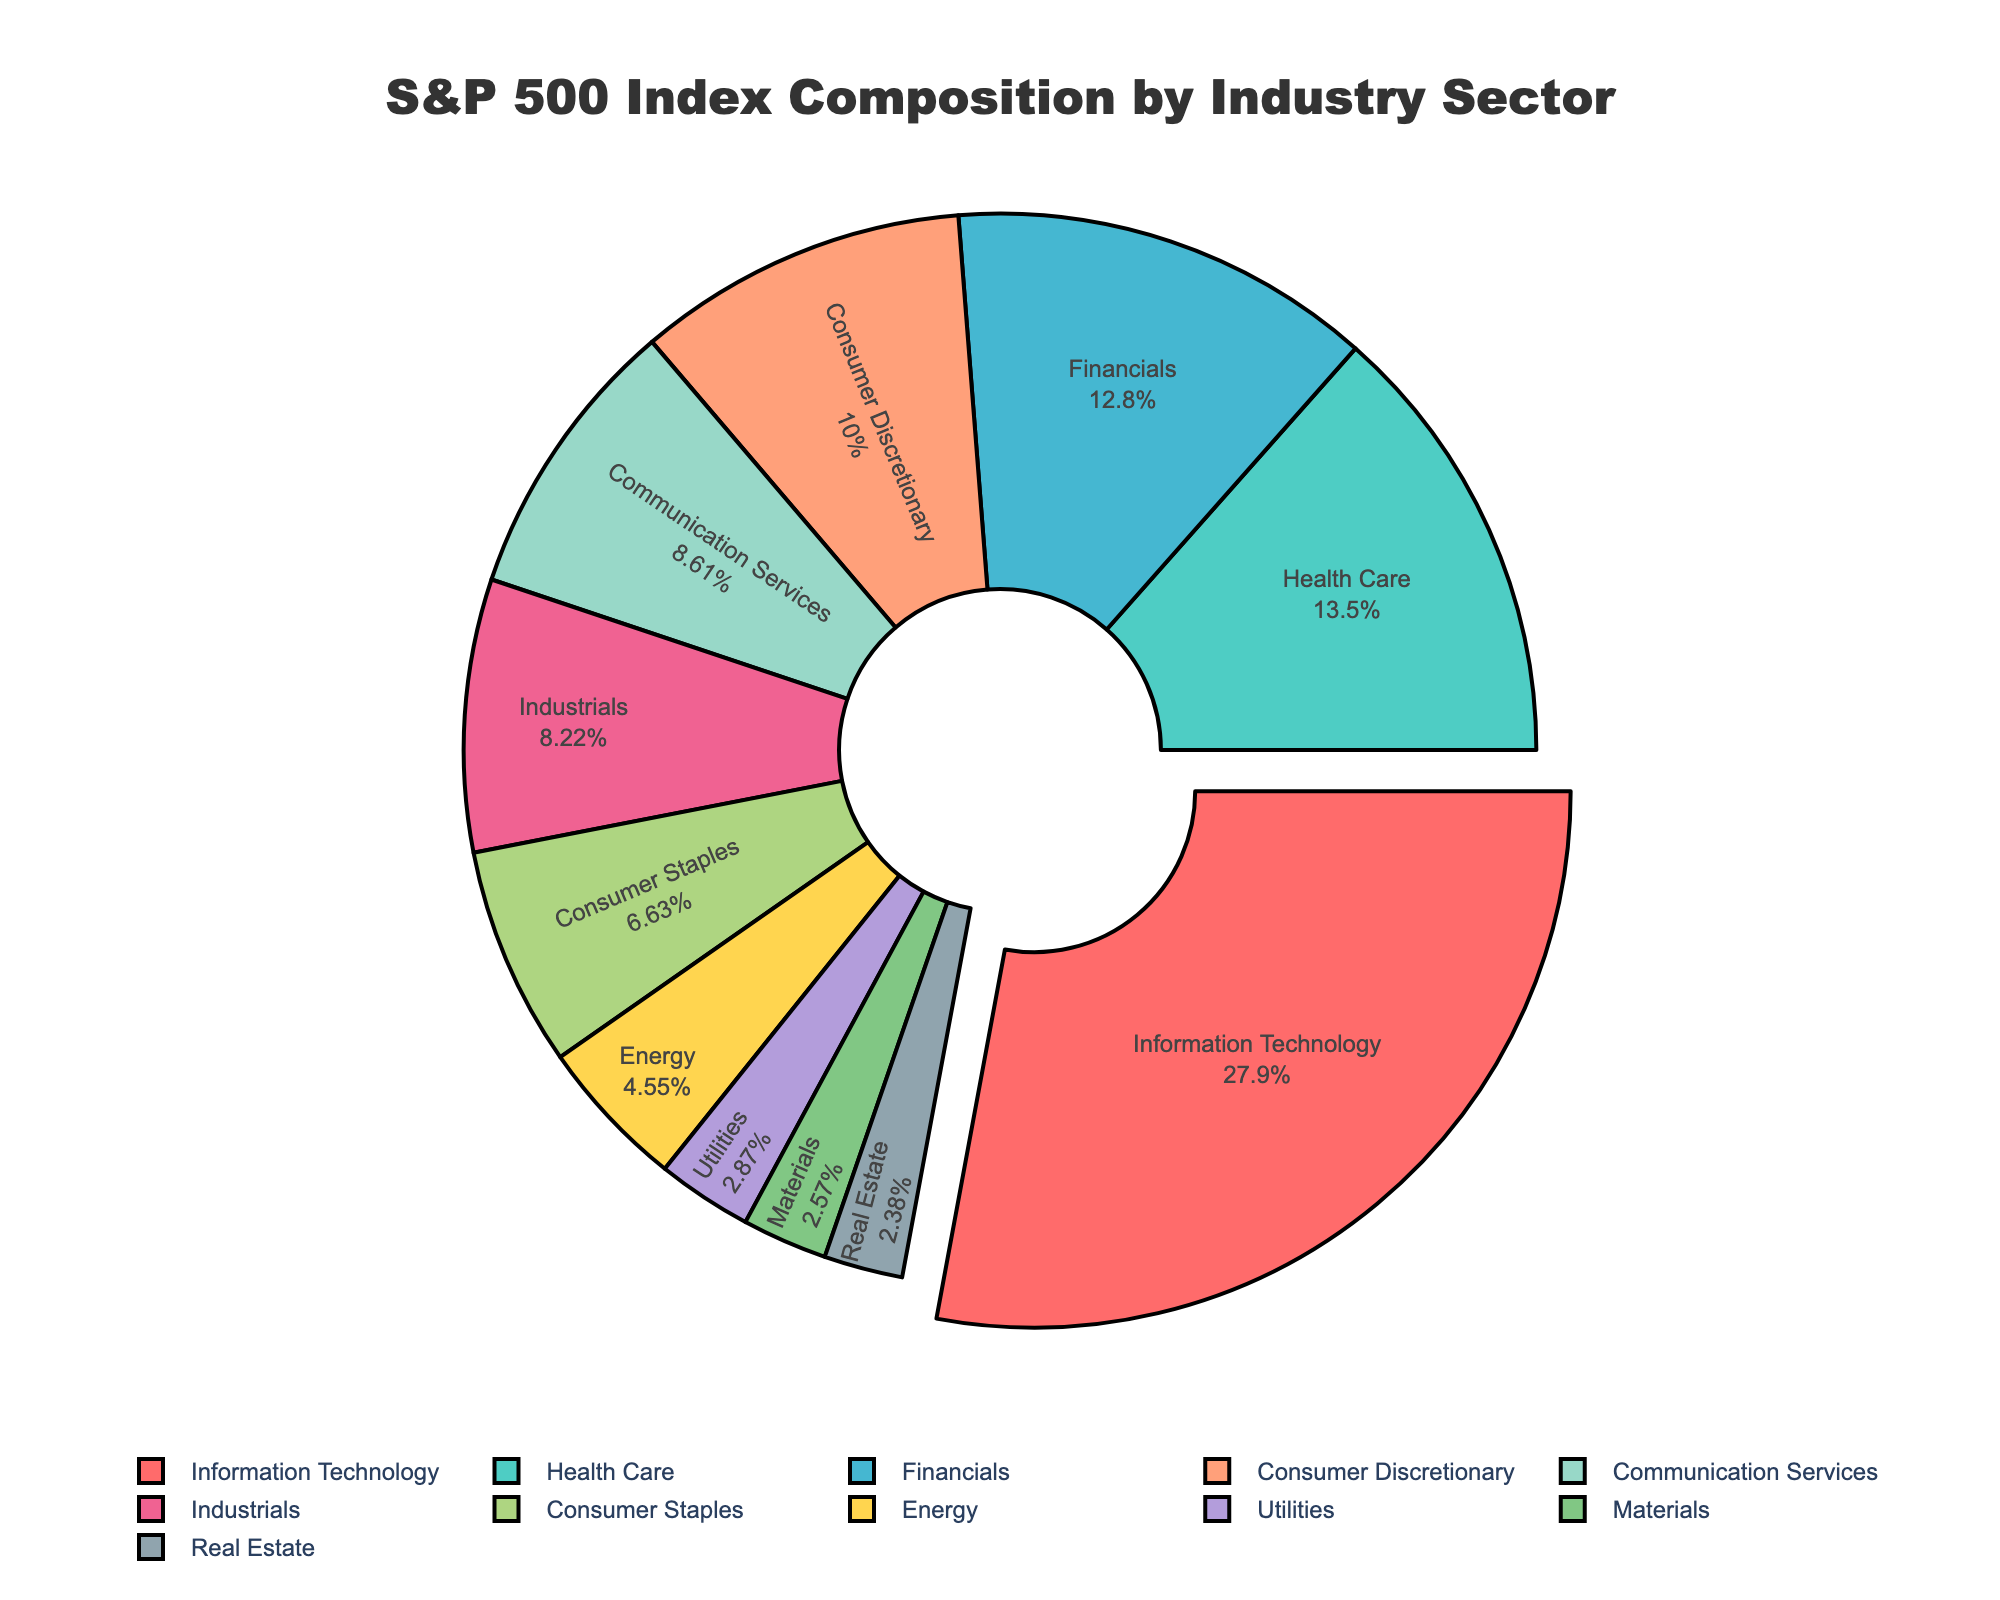Which sector has the largest share in the S&P 500 index? The Information Technology sector has the largest share. It is represented by the largest segment and a pull-out effect in the pie chart, indicating it holds the highest percentage.
Answer: Information Technology What is the combined percentage of the top three sectors? The top three sectors are Information Technology (28.2%), Health Care (13.6%), and Financials (12.9%). Adding these percentages together: 28.2 + 13.6 + 12.9 = 54.7%.
Answer: 54.7% How much larger is the share of Information Technology compared to Utilities? The share of Information Technology is 28.2% and Utilities is 2.9%. Subtracting the smaller value from the larger: 28.2 - 2.9 = 25.3%.
Answer: 25.3% Which sector occupies exactly half the share of Health Care? Health Care holds 13.6% of the share. The sector with exactly half of this value is Communication Services with 8.7%. Since we initially thought 6.8% is the approximate half of 13.6%, Communication Services is closely 6.8%.
Answer: Communication Services Are the shares of Financials and Consumer Discretionary close to each other? The Financials sector has a share of 12.9% and Consumer Discretionary has 10.1%. Comparing these two values shows they are relatively close, with a difference of 2.8%.
Answer: Yes What sectors have a smaller share than Energy? Energy has a share of 4.6%. Sectors with smaller shares are Utilities (2.9%), Materials (2.6%), and Real Estate (2.4%).
Answer: Utilities, Materials, Real Estate Which sectors combined make up about 25% of the index? Summing the shares of smaller sectors: Consumer Staples (6.7%), Energy (4.6%), Utilities (2.9%), Materials (2.6%), and Real Estate (2.4%) gives 19.2%. Adding Communication Services (8.7%) would exceed, but adding Information Technology (6.7%), and Consumer Staples (8.7%) would be around 25.4%. This way, combining Consumer Staples, Energy, Utilities, Materials, and Real Estate closely sums up approximately 23.8%.
Answer: Consumer Staples, Energy, Utilities, Materials, Real Estate What is the difference in percentage between Industrials and Consumer Staples? Industrials have a share of 8.3% and Consumer Staples have 6.7%. The difference: 8.3 - 6.7 = 1.6%.
Answer: 1.6% Which sector falls in the middle of the pie chart in terms of share? Sorting the sectors in descending order, Consumer Staples (6.7%) is in the middle when arranged this way.
Answer: Consumer Staples 